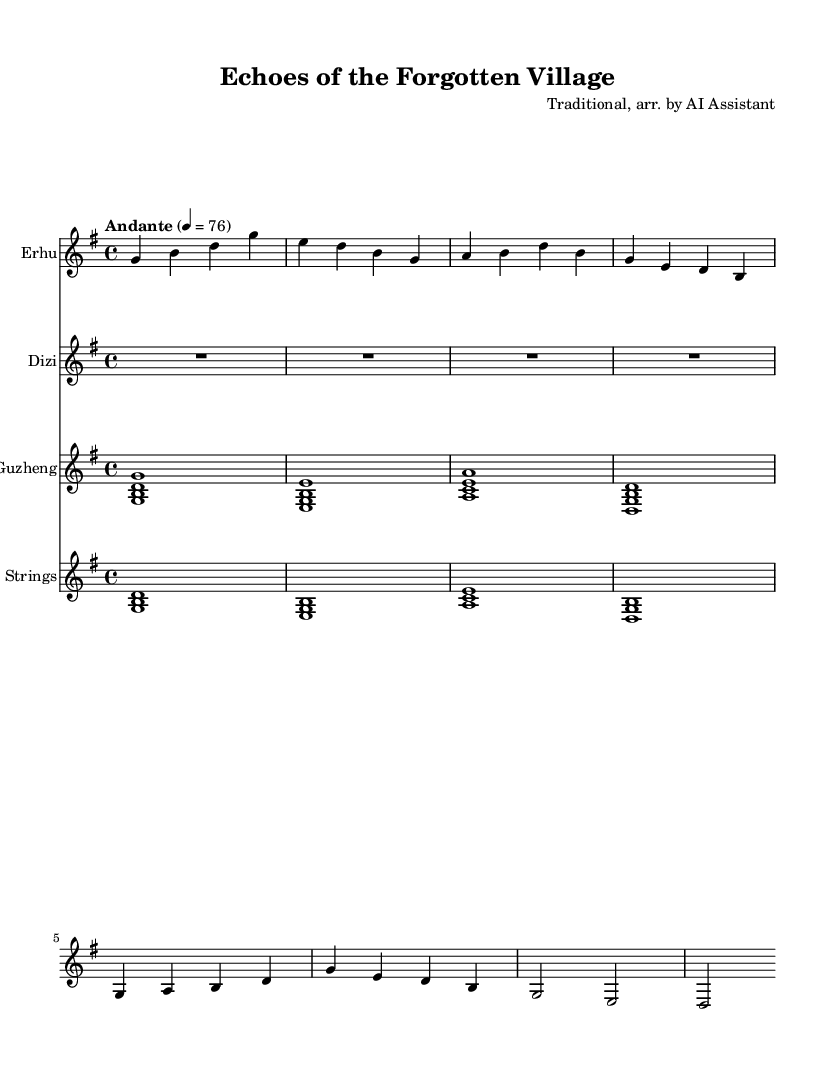What is the key signature of this music? The key signature is G major, which has one sharp (F#). This is indicated at the beginning of the music sheet next to the clef.
Answer: G major What is the time signature? The time signature is 4/4, which signifies four beats in each measure and that the quarter note gets one beat. This can be found at the beginning of the score, right after the key signature.
Answer: 4/4 What is the tempo marking? The tempo marking is "Andante" at a speed of 76 beats per minute, indicating a moderate pace. This is typically mentioned at the start of the score.
Answer: Andante 76 Which instrument does not have any notes in the first measure? The dizi does not have any notes in the first measure, as indicated by the "R1*4" which signifies a rest for the entire measure.
Answer: Dizi How many different instruments are featured in this score? There are four different instruments featured in this score: Erhu, Dizi, Guzheng, and Strings. This can be identified by the four distinct staves present in the score layout.
Answer: Four What is the first note played by the Erhu? The first note played by the Erhu is G, as shown at the beginning of the relative pitch notation for the Erhu staff.
Answer: G What chord is played by the Guzheng in the first measure? The chord played by the Guzheng in the first measure is G major, represented by the notes g, b, and d. This is indicated by the notation <g b d> in the score.
Answer: G major 